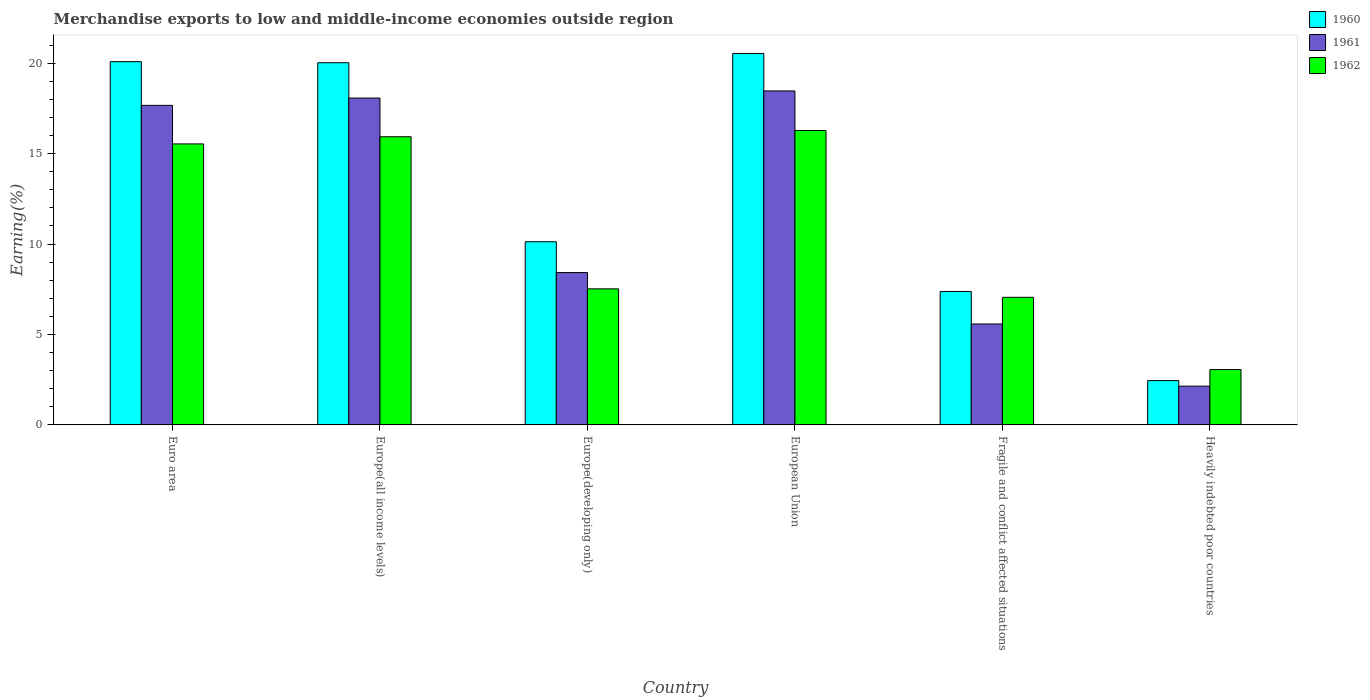How many groups of bars are there?
Give a very brief answer. 6. Are the number of bars per tick equal to the number of legend labels?
Make the answer very short. Yes. How many bars are there on the 1st tick from the right?
Make the answer very short. 3. What is the label of the 5th group of bars from the left?
Your answer should be very brief. Fragile and conflict affected situations. What is the percentage of amount earned from merchandise exports in 1961 in Europe(all income levels)?
Provide a short and direct response. 18.07. Across all countries, what is the maximum percentage of amount earned from merchandise exports in 1960?
Offer a terse response. 20.54. Across all countries, what is the minimum percentage of amount earned from merchandise exports in 1961?
Give a very brief answer. 2.14. In which country was the percentage of amount earned from merchandise exports in 1961 minimum?
Keep it short and to the point. Heavily indebted poor countries. What is the total percentage of amount earned from merchandise exports in 1962 in the graph?
Give a very brief answer. 65.38. What is the difference between the percentage of amount earned from merchandise exports in 1961 in Europe(all income levels) and that in Heavily indebted poor countries?
Give a very brief answer. 15.93. What is the difference between the percentage of amount earned from merchandise exports in 1962 in European Union and the percentage of amount earned from merchandise exports in 1960 in Fragile and conflict affected situations?
Offer a very short reply. 8.9. What is the average percentage of amount earned from merchandise exports in 1962 per country?
Make the answer very short. 10.9. What is the difference between the percentage of amount earned from merchandise exports of/in 1961 and percentage of amount earned from merchandise exports of/in 1960 in Euro area?
Your response must be concise. -2.42. What is the ratio of the percentage of amount earned from merchandise exports in 1961 in Europe(developing only) to that in Fragile and conflict affected situations?
Keep it short and to the point. 1.51. Is the percentage of amount earned from merchandise exports in 1961 in Europe(developing only) less than that in European Union?
Your answer should be compact. Yes. What is the difference between the highest and the second highest percentage of amount earned from merchandise exports in 1962?
Offer a terse response. 0.74. What is the difference between the highest and the lowest percentage of amount earned from merchandise exports in 1961?
Ensure brevity in your answer.  16.32. In how many countries, is the percentage of amount earned from merchandise exports in 1961 greater than the average percentage of amount earned from merchandise exports in 1961 taken over all countries?
Your response must be concise. 3. Is the sum of the percentage of amount earned from merchandise exports in 1960 in Europe(developing only) and Fragile and conflict affected situations greater than the maximum percentage of amount earned from merchandise exports in 1962 across all countries?
Offer a terse response. Yes. What does the 1st bar from the right in European Union represents?
Offer a terse response. 1962. How many bars are there?
Keep it short and to the point. 18. How many countries are there in the graph?
Ensure brevity in your answer.  6. Are the values on the major ticks of Y-axis written in scientific E-notation?
Your answer should be very brief. No. Does the graph contain any zero values?
Give a very brief answer. No. How many legend labels are there?
Make the answer very short. 3. What is the title of the graph?
Keep it short and to the point. Merchandise exports to low and middle-income economies outside region. Does "1995" appear as one of the legend labels in the graph?
Offer a very short reply. No. What is the label or title of the Y-axis?
Give a very brief answer. Earning(%). What is the Earning(%) in 1960 in Euro area?
Offer a very short reply. 20.08. What is the Earning(%) of 1961 in Euro area?
Keep it short and to the point. 17.67. What is the Earning(%) of 1962 in Euro area?
Make the answer very short. 15.54. What is the Earning(%) in 1960 in Europe(all income levels)?
Give a very brief answer. 20.02. What is the Earning(%) in 1961 in Europe(all income levels)?
Keep it short and to the point. 18.07. What is the Earning(%) in 1962 in Europe(all income levels)?
Make the answer very short. 15.93. What is the Earning(%) of 1960 in Europe(developing only)?
Your answer should be compact. 10.13. What is the Earning(%) in 1961 in Europe(developing only)?
Provide a short and direct response. 8.42. What is the Earning(%) in 1962 in Europe(developing only)?
Offer a terse response. 7.52. What is the Earning(%) in 1960 in European Union?
Your response must be concise. 20.54. What is the Earning(%) of 1961 in European Union?
Your answer should be very brief. 18.46. What is the Earning(%) in 1962 in European Union?
Provide a succinct answer. 16.28. What is the Earning(%) of 1960 in Fragile and conflict affected situations?
Your response must be concise. 7.38. What is the Earning(%) of 1961 in Fragile and conflict affected situations?
Keep it short and to the point. 5.58. What is the Earning(%) in 1962 in Fragile and conflict affected situations?
Offer a very short reply. 7.05. What is the Earning(%) in 1960 in Heavily indebted poor countries?
Give a very brief answer. 2.45. What is the Earning(%) of 1961 in Heavily indebted poor countries?
Provide a succinct answer. 2.14. What is the Earning(%) in 1962 in Heavily indebted poor countries?
Give a very brief answer. 3.06. Across all countries, what is the maximum Earning(%) in 1960?
Ensure brevity in your answer.  20.54. Across all countries, what is the maximum Earning(%) in 1961?
Your answer should be very brief. 18.46. Across all countries, what is the maximum Earning(%) in 1962?
Ensure brevity in your answer.  16.28. Across all countries, what is the minimum Earning(%) in 1960?
Provide a succinct answer. 2.45. Across all countries, what is the minimum Earning(%) of 1961?
Your answer should be very brief. 2.14. Across all countries, what is the minimum Earning(%) in 1962?
Offer a very short reply. 3.06. What is the total Earning(%) in 1960 in the graph?
Make the answer very short. 80.6. What is the total Earning(%) of 1961 in the graph?
Offer a very short reply. 70.35. What is the total Earning(%) of 1962 in the graph?
Your answer should be compact. 65.38. What is the difference between the Earning(%) of 1960 in Euro area and that in Europe(all income levels)?
Make the answer very short. 0.06. What is the difference between the Earning(%) of 1961 in Euro area and that in Europe(all income levels)?
Ensure brevity in your answer.  -0.4. What is the difference between the Earning(%) of 1962 in Euro area and that in Europe(all income levels)?
Keep it short and to the point. -0.4. What is the difference between the Earning(%) of 1960 in Euro area and that in Europe(developing only)?
Keep it short and to the point. 9.96. What is the difference between the Earning(%) of 1961 in Euro area and that in Europe(developing only)?
Offer a terse response. 9.24. What is the difference between the Earning(%) of 1962 in Euro area and that in Europe(developing only)?
Make the answer very short. 8.01. What is the difference between the Earning(%) of 1960 in Euro area and that in European Union?
Your answer should be compact. -0.45. What is the difference between the Earning(%) of 1961 in Euro area and that in European Union?
Provide a short and direct response. -0.8. What is the difference between the Earning(%) of 1962 in Euro area and that in European Union?
Your answer should be compact. -0.74. What is the difference between the Earning(%) in 1960 in Euro area and that in Fragile and conflict affected situations?
Your answer should be compact. 12.71. What is the difference between the Earning(%) of 1961 in Euro area and that in Fragile and conflict affected situations?
Provide a succinct answer. 12.09. What is the difference between the Earning(%) in 1962 in Euro area and that in Fragile and conflict affected situations?
Your response must be concise. 8.48. What is the difference between the Earning(%) in 1960 in Euro area and that in Heavily indebted poor countries?
Offer a very short reply. 17.63. What is the difference between the Earning(%) of 1961 in Euro area and that in Heavily indebted poor countries?
Provide a succinct answer. 15.52. What is the difference between the Earning(%) in 1962 in Euro area and that in Heavily indebted poor countries?
Keep it short and to the point. 12.47. What is the difference between the Earning(%) of 1960 in Europe(all income levels) and that in Europe(developing only)?
Keep it short and to the point. 9.9. What is the difference between the Earning(%) of 1961 in Europe(all income levels) and that in Europe(developing only)?
Keep it short and to the point. 9.65. What is the difference between the Earning(%) of 1962 in Europe(all income levels) and that in Europe(developing only)?
Keep it short and to the point. 8.41. What is the difference between the Earning(%) in 1960 in Europe(all income levels) and that in European Union?
Provide a succinct answer. -0.51. What is the difference between the Earning(%) of 1961 in Europe(all income levels) and that in European Union?
Ensure brevity in your answer.  -0.39. What is the difference between the Earning(%) of 1962 in Europe(all income levels) and that in European Union?
Your answer should be compact. -0.35. What is the difference between the Earning(%) in 1960 in Europe(all income levels) and that in Fragile and conflict affected situations?
Your answer should be very brief. 12.65. What is the difference between the Earning(%) of 1961 in Europe(all income levels) and that in Fragile and conflict affected situations?
Your answer should be very brief. 12.49. What is the difference between the Earning(%) of 1962 in Europe(all income levels) and that in Fragile and conflict affected situations?
Your answer should be very brief. 8.88. What is the difference between the Earning(%) of 1960 in Europe(all income levels) and that in Heavily indebted poor countries?
Ensure brevity in your answer.  17.57. What is the difference between the Earning(%) of 1961 in Europe(all income levels) and that in Heavily indebted poor countries?
Your answer should be very brief. 15.93. What is the difference between the Earning(%) of 1962 in Europe(all income levels) and that in Heavily indebted poor countries?
Your answer should be very brief. 12.87. What is the difference between the Earning(%) of 1960 in Europe(developing only) and that in European Union?
Provide a short and direct response. -10.41. What is the difference between the Earning(%) of 1961 in Europe(developing only) and that in European Union?
Keep it short and to the point. -10.04. What is the difference between the Earning(%) in 1962 in Europe(developing only) and that in European Union?
Keep it short and to the point. -8.76. What is the difference between the Earning(%) of 1960 in Europe(developing only) and that in Fragile and conflict affected situations?
Make the answer very short. 2.75. What is the difference between the Earning(%) of 1961 in Europe(developing only) and that in Fragile and conflict affected situations?
Provide a succinct answer. 2.84. What is the difference between the Earning(%) in 1962 in Europe(developing only) and that in Fragile and conflict affected situations?
Keep it short and to the point. 0.47. What is the difference between the Earning(%) in 1960 in Europe(developing only) and that in Heavily indebted poor countries?
Offer a terse response. 7.68. What is the difference between the Earning(%) of 1961 in Europe(developing only) and that in Heavily indebted poor countries?
Offer a terse response. 6.28. What is the difference between the Earning(%) in 1962 in Europe(developing only) and that in Heavily indebted poor countries?
Keep it short and to the point. 4.46. What is the difference between the Earning(%) of 1960 in European Union and that in Fragile and conflict affected situations?
Offer a very short reply. 13.16. What is the difference between the Earning(%) in 1961 in European Union and that in Fragile and conflict affected situations?
Provide a short and direct response. 12.88. What is the difference between the Earning(%) in 1962 in European Union and that in Fragile and conflict affected situations?
Make the answer very short. 9.22. What is the difference between the Earning(%) of 1960 in European Union and that in Heavily indebted poor countries?
Your answer should be compact. 18.09. What is the difference between the Earning(%) in 1961 in European Union and that in Heavily indebted poor countries?
Make the answer very short. 16.32. What is the difference between the Earning(%) of 1962 in European Union and that in Heavily indebted poor countries?
Your answer should be compact. 13.22. What is the difference between the Earning(%) of 1960 in Fragile and conflict affected situations and that in Heavily indebted poor countries?
Keep it short and to the point. 4.93. What is the difference between the Earning(%) in 1961 in Fragile and conflict affected situations and that in Heavily indebted poor countries?
Make the answer very short. 3.44. What is the difference between the Earning(%) in 1962 in Fragile and conflict affected situations and that in Heavily indebted poor countries?
Offer a terse response. 3.99. What is the difference between the Earning(%) of 1960 in Euro area and the Earning(%) of 1961 in Europe(all income levels)?
Your answer should be very brief. 2.01. What is the difference between the Earning(%) in 1960 in Euro area and the Earning(%) in 1962 in Europe(all income levels)?
Offer a very short reply. 4.15. What is the difference between the Earning(%) of 1961 in Euro area and the Earning(%) of 1962 in Europe(all income levels)?
Your response must be concise. 1.74. What is the difference between the Earning(%) of 1960 in Euro area and the Earning(%) of 1961 in Europe(developing only)?
Ensure brevity in your answer.  11.66. What is the difference between the Earning(%) in 1960 in Euro area and the Earning(%) in 1962 in Europe(developing only)?
Your response must be concise. 12.56. What is the difference between the Earning(%) in 1961 in Euro area and the Earning(%) in 1962 in Europe(developing only)?
Offer a very short reply. 10.14. What is the difference between the Earning(%) of 1960 in Euro area and the Earning(%) of 1961 in European Union?
Keep it short and to the point. 1.62. What is the difference between the Earning(%) in 1960 in Euro area and the Earning(%) in 1962 in European Union?
Your answer should be compact. 3.81. What is the difference between the Earning(%) in 1961 in Euro area and the Earning(%) in 1962 in European Union?
Ensure brevity in your answer.  1.39. What is the difference between the Earning(%) in 1960 in Euro area and the Earning(%) in 1961 in Fragile and conflict affected situations?
Your answer should be compact. 14.5. What is the difference between the Earning(%) in 1960 in Euro area and the Earning(%) in 1962 in Fragile and conflict affected situations?
Ensure brevity in your answer.  13.03. What is the difference between the Earning(%) in 1961 in Euro area and the Earning(%) in 1962 in Fragile and conflict affected situations?
Keep it short and to the point. 10.61. What is the difference between the Earning(%) in 1960 in Euro area and the Earning(%) in 1961 in Heavily indebted poor countries?
Make the answer very short. 17.94. What is the difference between the Earning(%) in 1960 in Euro area and the Earning(%) in 1962 in Heavily indebted poor countries?
Keep it short and to the point. 17.02. What is the difference between the Earning(%) in 1961 in Euro area and the Earning(%) in 1962 in Heavily indebted poor countries?
Ensure brevity in your answer.  14.61. What is the difference between the Earning(%) of 1960 in Europe(all income levels) and the Earning(%) of 1961 in Europe(developing only)?
Your response must be concise. 11.6. What is the difference between the Earning(%) in 1960 in Europe(all income levels) and the Earning(%) in 1962 in Europe(developing only)?
Provide a succinct answer. 12.5. What is the difference between the Earning(%) of 1961 in Europe(all income levels) and the Earning(%) of 1962 in Europe(developing only)?
Your answer should be very brief. 10.55. What is the difference between the Earning(%) in 1960 in Europe(all income levels) and the Earning(%) in 1961 in European Union?
Offer a very short reply. 1.56. What is the difference between the Earning(%) of 1960 in Europe(all income levels) and the Earning(%) of 1962 in European Union?
Your answer should be compact. 3.75. What is the difference between the Earning(%) of 1961 in Europe(all income levels) and the Earning(%) of 1962 in European Union?
Give a very brief answer. 1.79. What is the difference between the Earning(%) of 1960 in Europe(all income levels) and the Earning(%) of 1961 in Fragile and conflict affected situations?
Give a very brief answer. 14.44. What is the difference between the Earning(%) in 1960 in Europe(all income levels) and the Earning(%) in 1962 in Fragile and conflict affected situations?
Provide a succinct answer. 12.97. What is the difference between the Earning(%) in 1961 in Europe(all income levels) and the Earning(%) in 1962 in Fragile and conflict affected situations?
Offer a very short reply. 11.02. What is the difference between the Earning(%) in 1960 in Europe(all income levels) and the Earning(%) in 1961 in Heavily indebted poor countries?
Ensure brevity in your answer.  17.88. What is the difference between the Earning(%) in 1960 in Europe(all income levels) and the Earning(%) in 1962 in Heavily indebted poor countries?
Your answer should be compact. 16.96. What is the difference between the Earning(%) of 1961 in Europe(all income levels) and the Earning(%) of 1962 in Heavily indebted poor countries?
Ensure brevity in your answer.  15.01. What is the difference between the Earning(%) in 1960 in Europe(developing only) and the Earning(%) in 1961 in European Union?
Your response must be concise. -8.34. What is the difference between the Earning(%) in 1960 in Europe(developing only) and the Earning(%) in 1962 in European Union?
Make the answer very short. -6.15. What is the difference between the Earning(%) of 1961 in Europe(developing only) and the Earning(%) of 1962 in European Union?
Provide a short and direct response. -7.86. What is the difference between the Earning(%) of 1960 in Europe(developing only) and the Earning(%) of 1961 in Fragile and conflict affected situations?
Make the answer very short. 4.55. What is the difference between the Earning(%) in 1960 in Europe(developing only) and the Earning(%) in 1962 in Fragile and conflict affected situations?
Provide a succinct answer. 3.07. What is the difference between the Earning(%) in 1961 in Europe(developing only) and the Earning(%) in 1962 in Fragile and conflict affected situations?
Offer a terse response. 1.37. What is the difference between the Earning(%) of 1960 in Europe(developing only) and the Earning(%) of 1961 in Heavily indebted poor countries?
Your answer should be very brief. 7.98. What is the difference between the Earning(%) of 1960 in Europe(developing only) and the Earning(%) of 1962 in Heavily indebted poor countries?
Offer a terse response. 7.07. What is the difference between the Earning(%) in 1961 in Europe(developing only) and the Earning(%) in 1962 in Heavily indebted poor countries?
Offer a very short reply. 5.36. What is the difference between the Earning(%) of 1960 in European Union and the Earning(%) of 1961 in Fragile and conflict affected situations?
Keep it short and to the point. 14.96. What is the difference between the Earning(%) in 1960 in European Union and the Earning(%) in 1962 in Fragile and conflict affected situations?
Ensure brevity in your answer.  13.48. What is the difference between the Earning(%) of 1961 in European Union and the Earning(%) of 1962 in Fragile and conflict affected situations?
Provide a succinct answer. 11.41. What is the difference between the Earning(%) in 1960 in European Union and the Earning(%) in 1961 in Heavily indebted poor countries?
Provide a short and direct response. 18.39. What is the difference between the Earning(%) of 1960 in European Union and the Earning(%) of 1962 in Heavily indebted poor countries?
Your response must be concise. 17.48. What is the difference between the Earning(%) in 1961 in European Union and the Earning(%) in 1962 in Heavily indebted poor countries?
Keep it short and to the point. 15.4. What is the difference between the Earning(%) of 1960 in Fragile and conflict affected situations and the Earning(%) of 1961 in Heavily indebted poor countries?
Provide a short and direct response. 5.23. What is the difference between the Earning(%) of 1960 in Fragile and conflict affected situations and the Earning(%) of 1962 in Heavily indebted poor countries?
Give a very brief answer. 4.32. What is the difference between the Earning(%) of 1961 in Fragile and conflict affected situations and the Earning(%) of 1962 in Heavily indebted poor countries?
Ensure brevity in your answer.  2.52. What is the average Earning(%) of 1960 per country?
Make the answer very short. 13.43. What is the average Earning(%) of 1961 per country?
Provide a short and direct response. 11.72. What is the average Earning(%) in 1962 per country?
Provide a short and direct response. 10.9. What is the difference between the Earning(%) of 1960 and Earning(%) of 1961 in Euro area?
Your response must be concise. 2.42. What is the difference between the Earning(%) of 1960 and Earning(%) of 1962 in Euro area?
Ensure brevity in your answer.  4.55. What is the difference between the Earning(%) of 1961 and Earning(%) of 1962 in Euro area?
Offer a very short reply. 2.13. What is the difference between the Earning(%) of 1960 and Earning(%) of 1961 in Europe(all income levels)?
Offer a terse response. 1.95. What is the difference between the Earning(%) in 1960 and Earning(%) in 1962 in Europe(all income levels)?
Make the answer very short. 4.09. What is the difference between the Earning(%) in 1961 and Earning(%) in 1962 in Europe(all income levels)?
Offer a terse response. 2.14. What is the difference between the Earning(%) in 1960 and Earning(%) in 1961 in Europe(developing only)?
Offer a very short reply. 1.7. What is the difference between the Earning(%) in 1960 and Earning(%) in 1962 in Europe(developing only)?
Keep it short and to the point. 2.6. What is the difference between the Earning(%) of 1961 and Earning(%) of 1962 in Europe(developing only)?
Ensure brevity in your answer.  0.9. What is the difference between the Earning(%) of 1960 and Earning(%) of 1961 in European Union?
Your answer should be compact. 2.07. What is the difference between the Earning(%) in 1960 and Earning(%) in 1962 in European Union?
Ensure brevity in your answer.  4.26. What is the difference between the Earning(%) of 1961 and Earning(%) of 1962 in European Union?
Keep it short and to the point. 2.19. What is the difference between the Earning(%) of 1960 and Earning(%) of 1961 in Fragile and conflict affected situations?
Make the answer very short. 1.8. What is the difference between the Earning(%) of 1960 and Earning(%) of 1962 in Fragile and conflict affected situations?
Offer a terse response. 0.32. What is the difference between the Earning(%) in 1961 and Earning(%) in 1962 in Fragile and conflict affected situations?
Make the answer very short. -1.47. What is the difference between the Earning(%) of 1960 and Earning(%) of 1961 in Heavily indebted poor countries?
Your answer should be very brief. 0.31. What is the difference between the Earning(%) in 1960 and Earning(%) in 1962 in Heavily indebted poor countries?
Give a very brief answer. -0.61. What is the difference between the Earning(%) of 1961 and Earning(%) of 1962 in Heavily indebted poor countries?
Provide a succinct answer. -0.92. What is the ratio of the Earning(%) in 1961 in Euro area to that in Europe(all income levels)?
Your response must be concise. 0.98. What is the ratio of the Earning(%) in 1962 in Euro area to that in Europe(all income levels)?
Your answer should be very brief. 0.98. What is the ratio of the Earning(%) in 1960 in Euro area to that in Europe(developing only)?
Offer a terse response. 1.98. What is the ratio of the Earning(%) in 1961 in Euro area to that in Europe(developing only)?
Provide a short and direct response. 2.1. What is the ratio of the Earning(%) of 1962 in Euro area to that in Europe(developing only)?
Offer a terse response. 2.07. What is the ratio of the Earning(%) in 1960 in Euro area to that in European Union?
Provide a short and direct response. 0.98. What is the ratio of the Earning(%) in 1961 in Euro area to that in European Union?
Your answer should be very brief. 0.96. What is the ratio of the Earning(%) in 1962 in Euro area to that in European Union?
Offer a very short reply. 0.95. What is the ratio of the Earning(%) of 1960 in Euro area to that in Fragile and conflict affected situations?
Make the answer very short. 2.72. What is the ratio of the Earning(%) in 1961 in Euro area to that in Fragile and conflict affected situations?
Make the answer very short. 3.17. What is the ratio of the Earning(%) of 1962 in Euro area to that in Fragile and conflict affected situations?
Your answer should be compact. 2.2. What is the ratio of the Earning(%) of 1960 in Euro area to that in Heavily indebted poor countries?
Your answer should be very brief. 8.2. What is the ratio of the Earning(%) of 1961 in Euro area to that in Heavily indebted poor countries?
Provide a succinct answer. 8.24. What is the ratio of the Earning(%) in 1962 in Euro area to that in Heavily indebted poor countries?
Keep it short and to the point. 5.08. What is the ratio of the Earning(%) in 1960 in Europe(all income levels) to that in Europe(developing only)?
Your answer should be very brief. 1.98. What is the ratio of the Earning(%) of 1961 in Europe(all income levels) to that in Europe(developing only)?
Provide a succinct answer. 2.15. What is the ratio of the Earning(%) in 1962 in Europe(all income levels) to that in Europe(developing only)?
Ensure brevity in your answer.  2.12. What is the ratio of the Earning(%) in 1961 in Europe(all income levels) to that in European Union?
Keep it short and to the point. 0.98. What is the ratio of the Earning(%) of 1962 in Europe(all income levels) to that in European Union?
Your answer should be very brief. 0.98. What is the ratio of the Earning(%) in 1960 in Europe(all income levels) to that in Fragile and conflict affected situations?
Give a very brief answer. 2.71. What is the ratio of the Earning(%) in 1961 in Europe(all income levels) to that in Fragile and conflict affected situations?
Keep it short and to the point. 3.24. What is the ratio of the Earning(%) in 1962 in Europe(all income levels) to that in Fragile and conflict affected situations?
Your answer should be very brief. 2.26. What is the ratio of the Earning(%) in 1960 in Europe(all income levels) to that in Heavily indebted poor countries?
Your response must be concise. 8.17. What is the ratio of the Earning(%) in 1961 in Europe(all income levels) to that in Heavily indebted poor countries?
Offer a very short reply. 8.43. What is the ratio of the Earning(%) in 1962 in Europe(all income levels) to that in Heavily indebted poor countries?
Ensure brevity in your answer.  5.2. What is the ratio of the Earning(%) in 1960 in Europe(developing only) to that in European Union?
Keep it short and to the point. 0.49. What is the ratio of the Earning(%) in 1961 in Europe(developing only) to that in European Union?
Your response must be concise. 0.46. What is the ratio of the Earning(%) in 1962 in Europe(developing only) to that in European Union?
Offer a very short reply. 0.46. What is the ratio of the Earning(%) of 1960 in Europe(developing only) to that in Fragile and conflict affected situations?
Provide a succinct answer. 1.37. What is the ratio of the Earning(%) of 1961 in Europe(developing only) to that in Fragile and conflict affected situations?
Ensure brevity in your answer.  1.51. What is the ratio of the Earning(%) of 1962 in Europe(developing only) to that in Fragile and conflict affected situations?
Ensure brevity in your answer.  1.07. What is the ratio of the Earning(%) in 1960 in Europe(developing only) to that in Heavily indebted poor countries?
Provide a succinct answer. 4.13. What is the ratio of the Earning(%) in 1961 in Europe(developing only) to that in Heavily indebted poor countries?
Ensure brevity in your answer.  3.93. What is the ratio of the Earning(%) in 1962 in Europe(developing only) to that in Heavily indebted poor countries?
Your response must be concise. 2.46. What is the ratio of the Earning(%) in 1960 in European Union to that in Fragile and conflict affected situations?
Your answer should be compact. 2.78. What is the ratio of the Earning(%) in 1961 in European Union to that in Fragile and conflict affected situations?
Provide a short and direct response. 3.31. What is the ratio of the Earning(%) in 1962 in European Union to that in Fragile and conflict affected situations?
Make the answer very short. 2.31. What is the ratio of the Earning(%) of 1960 in European Union to that in Heavily indebted poor countries?
Ensure brevity in your answer.  8.38. What is the ratio of the Earning(%) in 1961 in European Union to that in Heavily indebted poor countries?
Provide a short and direct response. 8.61. What is the ratio of the Earning(%) in 1962 in European Union to that in Heavily indebted poor countries?
Give a very brief answer. 5.32. What is the ratio of the Earning(%) of 1960 in Fragile and conflict affected situations to that in Heavily indebted poor countries?
Provide a succinct answer. 3.01. What is the ratio of the Earning(%) in 1961 in Fragile and conflict affected situations to that in Heavily indebted poor countries?
Offer a very short reply. 2.6. What is the ratio of the Earning(%) in 1962 in Fragile and conflict affected situations to that in Heavily indebted poor countries?
Provide a succinct answer. 2.3. What is the difference between the highest and the second highest Earning(%) of 1960?
Keep it short and to the point. 0.45. What is the difference between the highest and the second highest Earning(%) in 1961?
Your response must be concise. 0.39. What is the difference between the highest and the second highest Earning(%) of 1962?
Keep it short and to the point. 0.35. What is the difference between the highest and the lowest Earning(%) of 1960?
Provide a short and direct response. 18.09. What is the difference between the highest and the lowest Earning(%) of 1961?
Provide a succinct answer. 16.32. What is the difference between the highest and the lowest Earning(%) in 1962?
Provide a short and direct response. 13.22. 